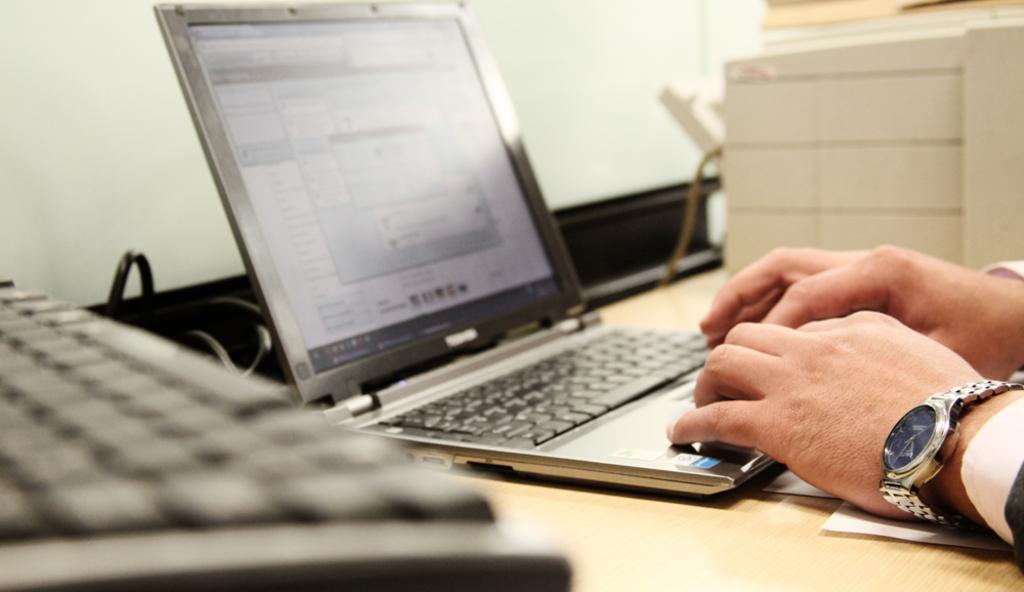What is the main object in the center of the image? There is a laptop in the center of the image. What else can be seen in the center of the image? There is a cable, a paper, and a person's hand visible in the center of the image. What is located on the left side of the image? There is a keyboard on the left side of the image. What is located on the right side of the image? There is a desktop on the right side of the image. How would you describe the lighting in the image? The background of the image is well-lit. How does the wind affect the laptop in the image? There is no wind present in the image, so it does not affect the laptop. What day of the week is depicted in the image? The day of the week is not visible or mentioned in the image, so it cannot be determined. 